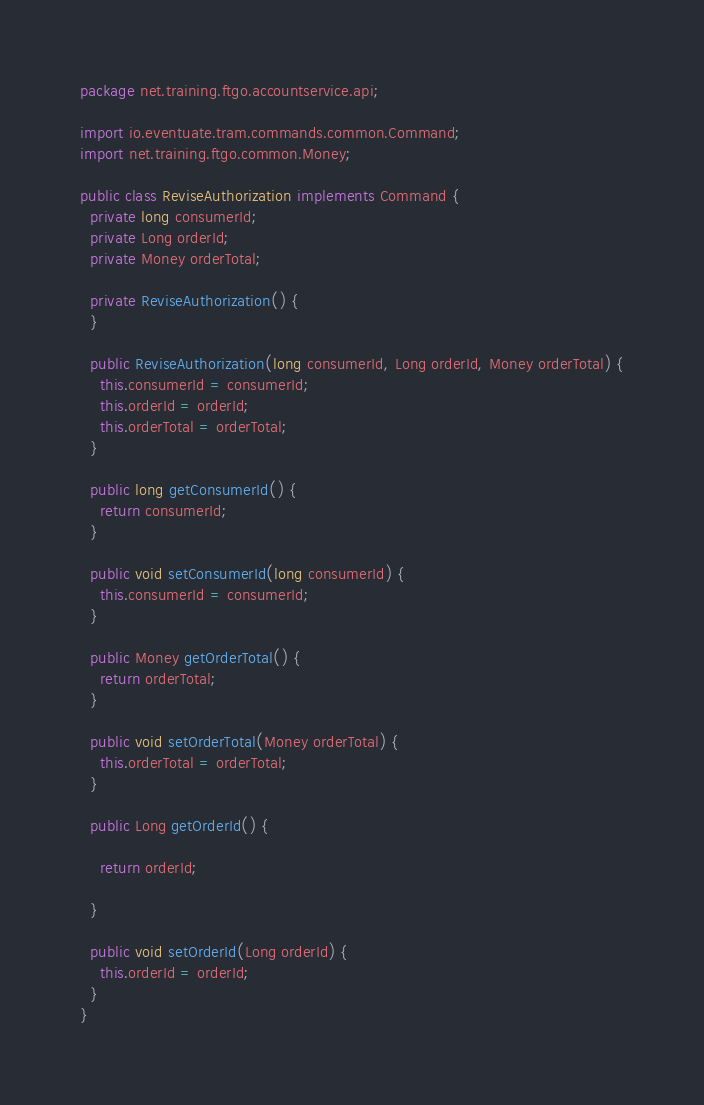Convert code to text. <code><loc_0><loc_0><loc_500><loc_500><_Java_>package net.training.ftgo.accountservice.api;

import io.eventuate.tram.commands.common.Command;
import net.training.ftgo.common.Money;

public class ReviseAuthorization implements Command {
  private long consumerId;
  private Long orderId;
  private Money orderTotal;

  private ReviseAuthorization() {
  }

  public ReviseAuthorization(long consumerId, Long orderId, Money orderTotal) {
    this.consumerId = consumerId;
    this.orderId = orderId;
    this.orderTotal = orderTotal;
  }

  public long getConsumerId() {
    return consumerId;
  }

  public void setConsumerId(long consumerId) {
    this.consumerId = consumerId;
  }

  public Money getOrderTotal() {
    return orderTotal;
  }

  public void setOrderTotal(Money orderTotal) {
    this.orderTotal = orderTotal;
  }

  public Long getOrderId() {

    return orderId;

  }

  public void setOrderId(Long orderId) {
    this.orderId = orderId;
  }
}
</code> 